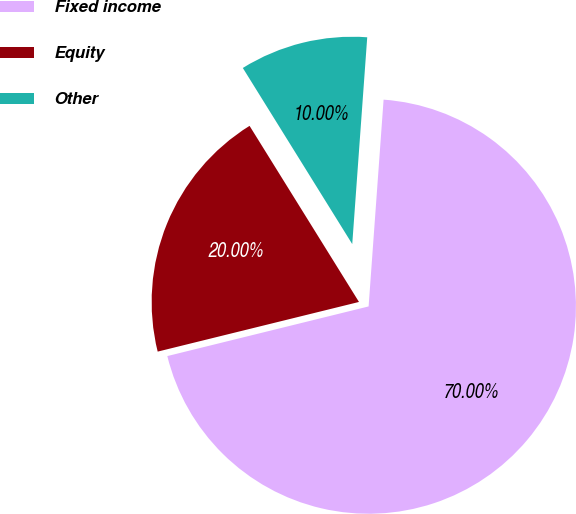Convert chart. <chart><loc_0><loc_0><loc_500><loc_500><pie_chart><fcel>Fixed income<fcel>Equity<fcel>Other<nl><fcel>70.0%<fcel>20.0%<fcel>10.0%<nl></chart> 